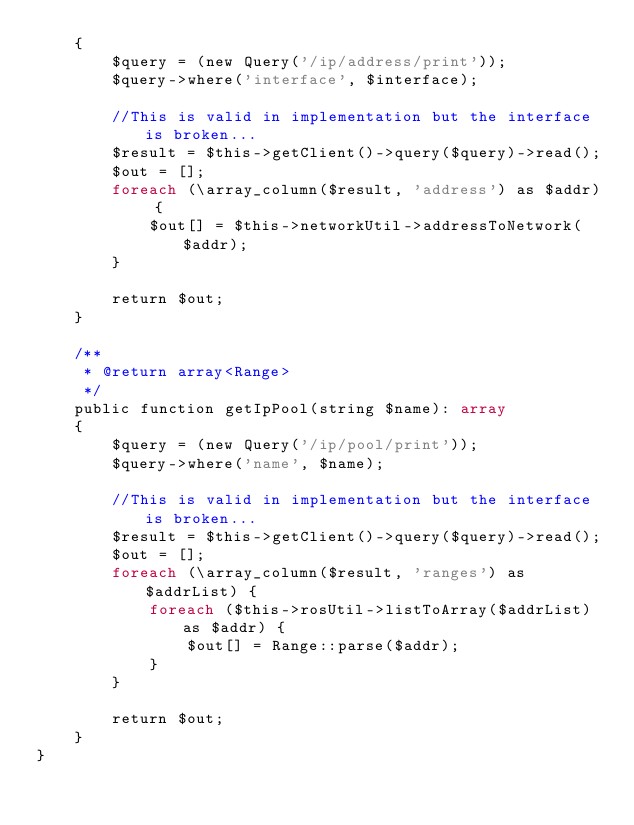<code> <loc_0><loc_0><loc_500><loc_500><_PHP_>    {
        $query = (new Query('/ip/address/print'));
        $query->where('interface', $interface);

        //This is valid in implementation but the interface is broken...
        $result = $this->getClient()->query($query)->read();
        $out = [];
        foreach (\array_column($result, 'address') as $addr) {
            $out[] = $this->networkUtil->addressToNetwork($addr);
        }

        return $out;
    }

    /**
     * @return array<Range>
     */
    public function getIpPool(string $name): array
    {
        $query = (new Query('/ip/pool/print'));
        $query->where('name', $name);

        //This is valid in implementation but the interface is broken...
        $result = $this->getClient()->query($query)->read();
        $out = [];
        foreach (\array_column($result, 'ranges') as $addrList) {
            foreach ($this->rosUtil->listToArray($addrList) as $addr) {
                $out[] = Range::parse($addr);
            }
        }

        return $out;
    }
}
</code> 